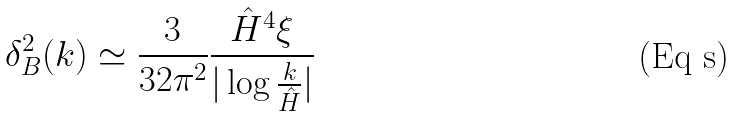<formula> <loc_0><loc_0><loc_500><loc_500>\delta ^ { 2 } _ { B } ( k ) \simeq \frac { 3 } { 3 2 \pi ^ { 2 } } \frac { \hat { H } ^ { 4 } \xi } { | \log { \frac { k } { \hat { H } } } | }</formula> 